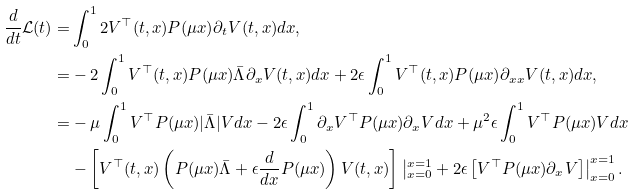Convert formula to latex. <formula><loc_0><loc_0><loc_500><loc_500>\frac { d } { d t } \mathcal { L } ( t ) = & \int _ { 0 } ^ { 1 } 2 V ^ { \top } ( t , x ) P ( \mu x ) \partial _ { t } V ( t , x ) d x , \\ = & - 2 \int _ { 0 } ^ { 1 } V ^ { \top } ( t , x ) P ( \mu x ) \bar { \Lambda } \partial _ { x } V ( t , x ) d x + 2 \epsilon \int _ { 0 } ^ { 1 } V ^ { \top } ( t , x ) P ( \mu x ) \partial _ { x x } V ( t , x ) d x , \\ = & - \mu \int _ { 0 } ^ { 1 } V ^ { \top } P ( \mu x ) | \bar { \Lambda } | V d x - 2 \epsilon \int _ { 0 } ^ { 1 } \partial _ { x } V ^ { \top } P ( \mu x ) \partial _ { x } V d x + \mu ^ { 2 } \epsilon \int _ { 0 } ^ { 1 } V ^ { \top } P ( \mu x ) V d x \\ & - \left [ V ^ { \top } ( t , x ) \left ( P ( \mu x ) \bar { \Lambda } + \epsilon \frac { d } { d x } P ( \mu x ) \right ) V ( t , x ) \right ] \left | _ { x = 0 } ^ { x = 1 } + 2 \epsilon \left [ V ^ { \top } P ( \mu x ) \partial _ { x } V \right ] \right | _ { x = 0 } ^ { x = 1 } .</formula> 